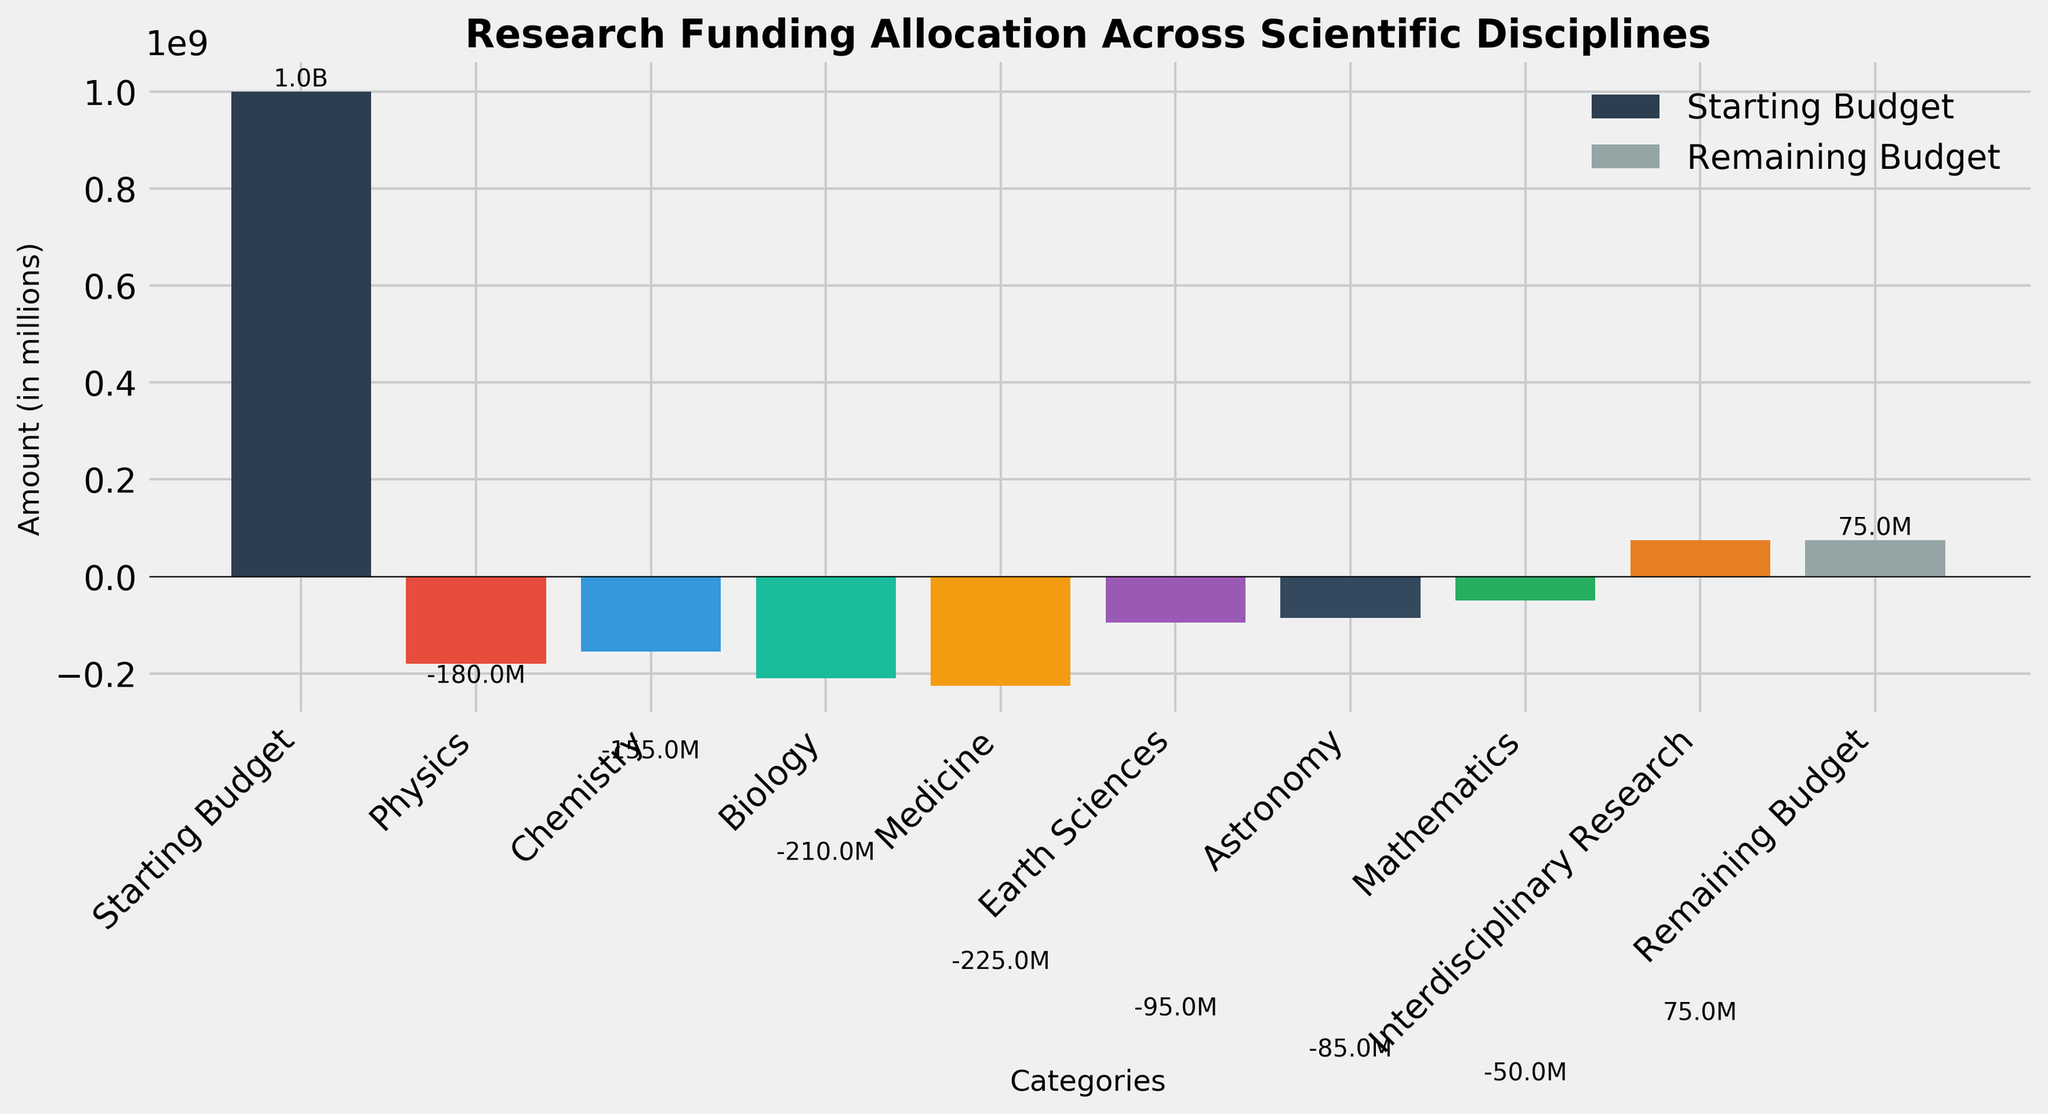What's the title of the figure? The title of the figure is displayed at the top of the chart. It summarizes the content and context of the data presented.
Answer: Research Funding Allocation Across Scientific Disciplines What is the starting budget? The starting budget is indicated by the first bar in the chart, which is labeled "Starting Budget". The label at the top of the bar shows its value.
Answer: 1.0B How much more funding did Biology receive compared to Mathematics? To find the difference, locate the bar for Biology and the bar for Mathematics. Sum the absolute values of the two amounts. Biology received 210M and Mathematics received 50M, so the difference is 210M - 50M = 160M.
Answer: 160M What is the remaining budget after all allocations? The remaining budget is shown by the last bar in the chart, labeled "Remaining Budget". The label on the bar indicates the final budget value.
Answer: 75M Which two categories received the smallest allocations? To identify this, compare the heights of all the bars that represent negative amounts. The categories with the smallest (least negative) allocations are the shortest bars excluding the "Starting Budget" and "Remaining Budget". The two smallest are Astronomy (85M) and Mathematics (50M).
Answer: Astronomy and Mathematics What is the total allocation given to Chemistry and Medicine combined? Sum the amounts for Chemistry and Medicine by looking at their respective bars. Chemistry received 155M and Medicine received 225M. The total allocation is 155M + 225M = 380M.
Answer: 380M How does the allocation to Earth Sciences compare to that of Chemistry? Locate the bars for Earth Sciences and Chemistry. The allocation for Earth Sciences is 95M and for Chemistry is 155M. Compare their values directly. Earth Sciences received less.
Answer: Earth Sciences received less What is the net effect of all negative and positive amounts? Sum all the amounts from the given data, taking into account their signs (positive or negative). The amounts are: -180M, -155M, -210M, -225M, -95M, -85M, -50M, +75M. The net effect is: (-180 - 155 - 210 - 225 - 95 - 85 - 50 + 75)M = -925M.
Answer: -925M Which category received the most funding? Identify the bar with the highest negative amount, as it denotes the largest allocation. This can be determined visually as well. Medicine received the most funding at 225M.
Answer: Medicine 